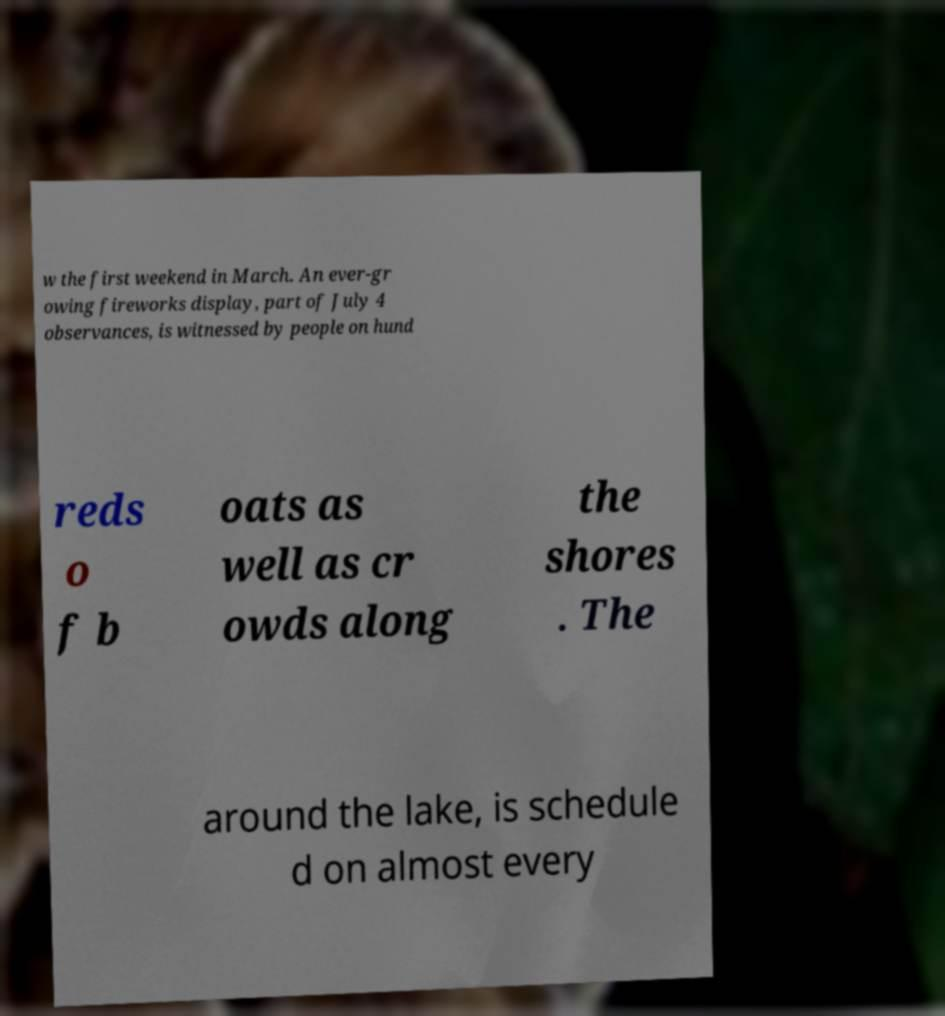What messages or text are displayed in this image? I need them in a readable, typed format. w the first weekend in March. An ever-gr owing fireworks display, part of July 4 observances, is witnessed by people on hund reds o f b oats as well as cr owds along the shores . The around the lake, is schedule d on almost every 